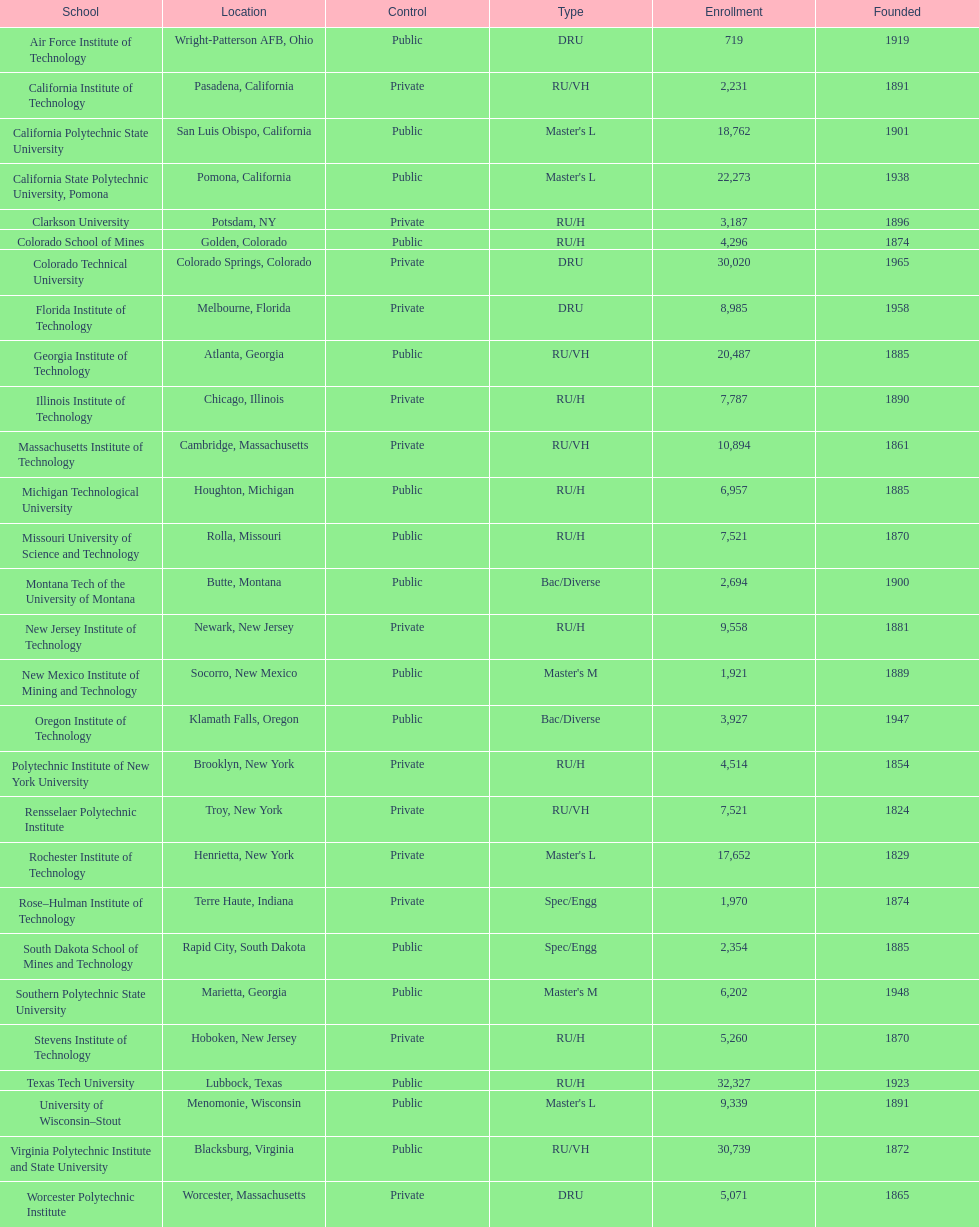In the table, what is the total number of schools displayed? 28. 